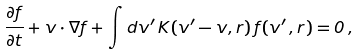Convert formula to latex. <formula><loc_0><loc_0><loc_500><loc_500>\frac { \partial f } { \partial t } + { v } \cdot \nabla f + \int d { v } ^ { \prime } \, K ( { v } ^ { \prime } - { v } , { r } ) \, f ( { v } ^ { \prime } \, , { r } ) = 0 \, ,</formula> 